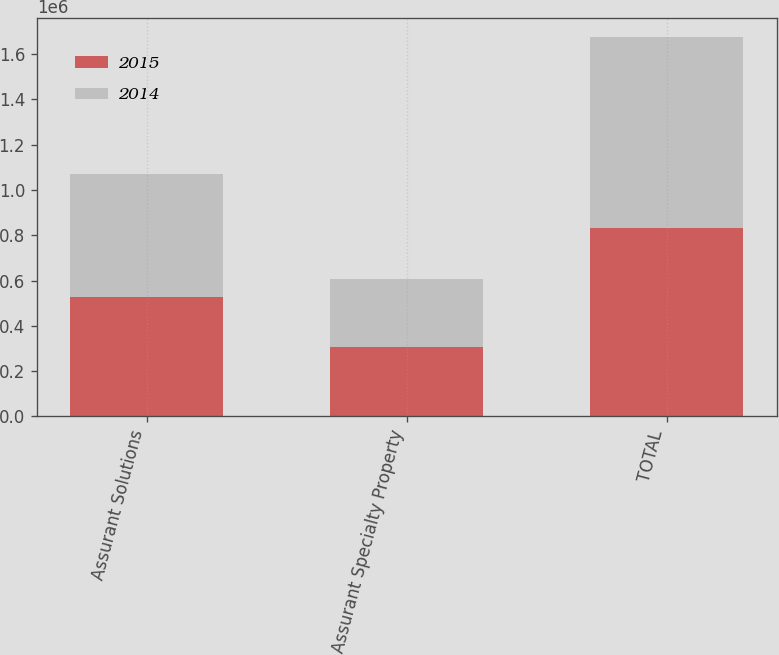Convert chart. <chart><loc_0><loc_0><loc_500><loc_500><stacked_bar_chart><ecel><fcel>Assurant Solutions<fcel>Assurant Specialty Property<fcel>TOTAL<nl><fcel>2015<fcel>529093<fcel>304419<fcel>833512<nl><fcel>2014<fcel>539653<fcel>301586<fcel>841239<nl></chart> 